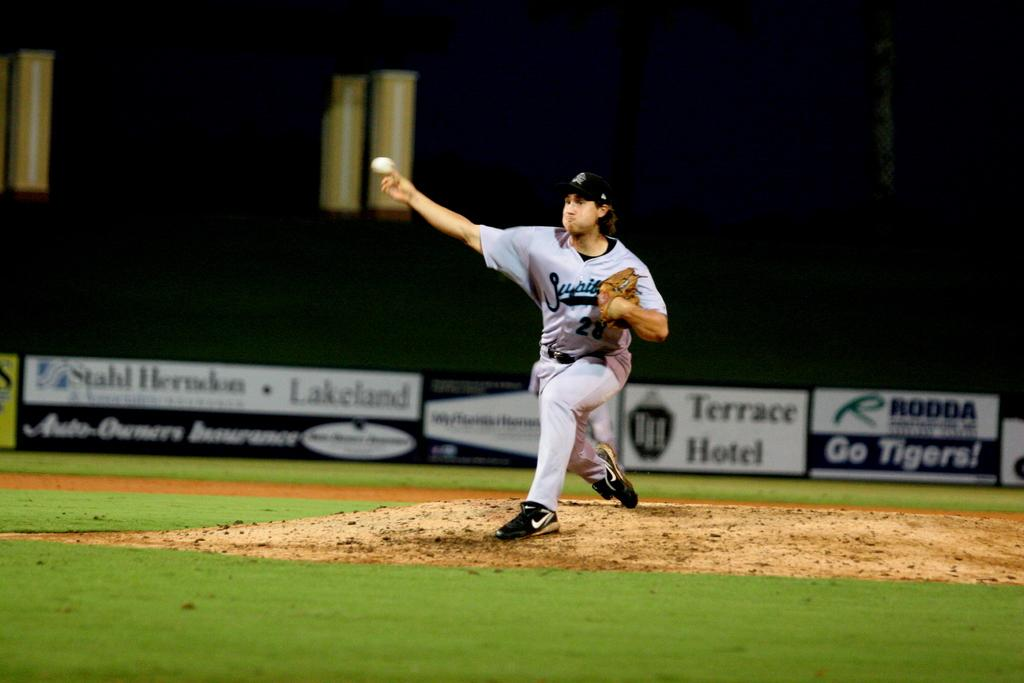<image>
Share a concise interpretation of the image provided. A baseball player pitches the ball during a game with a Terrace Hotel banner in the background. 